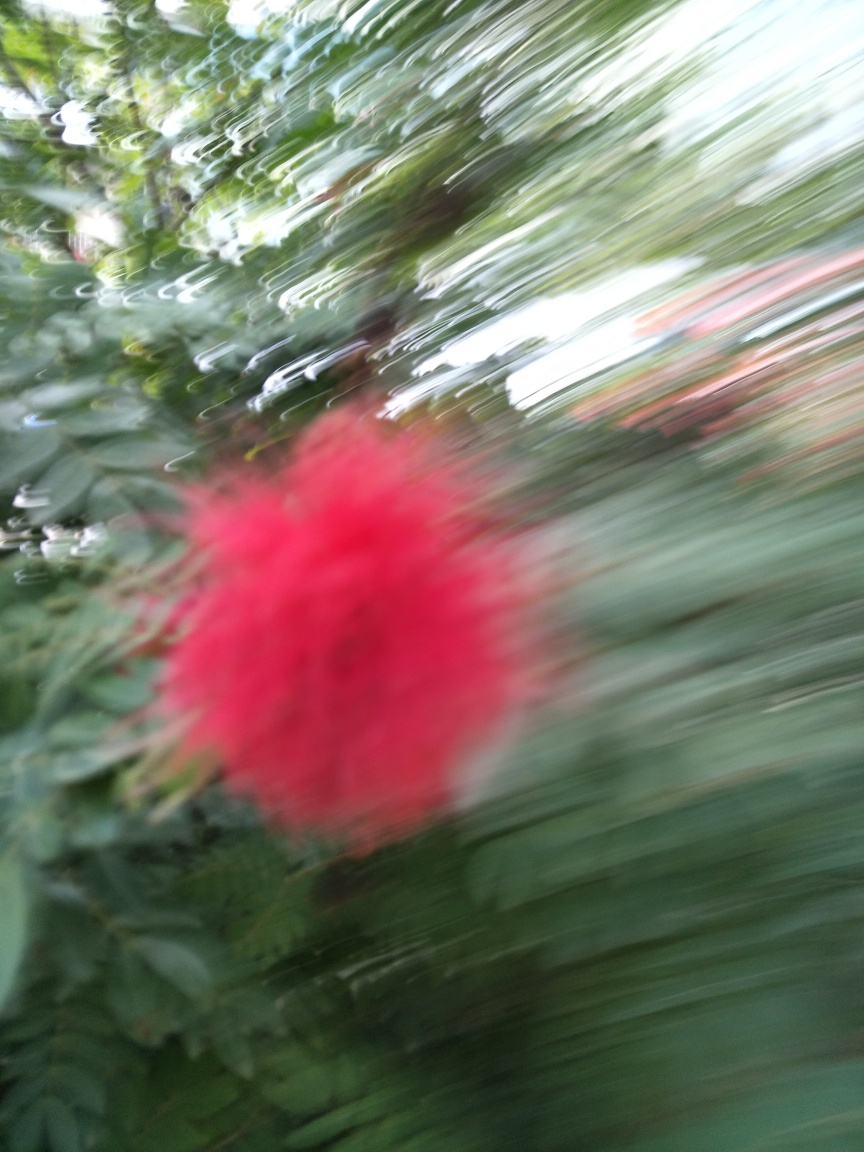Can you suggest some improvements to take a clearer picture? To take a clearer picture, it's important to ensure the camera is stable, perhaps by using a tripod or bracing against a solid surface. Using a faster shutter speed can also help freeze motion and reduce blur. Is there a best time of day to capture such images? The best time of day for clear and vivid plant photography is usually during the golden hour, shortly after sunrise or before sunset, when the sunlight is softer and more diffused. 